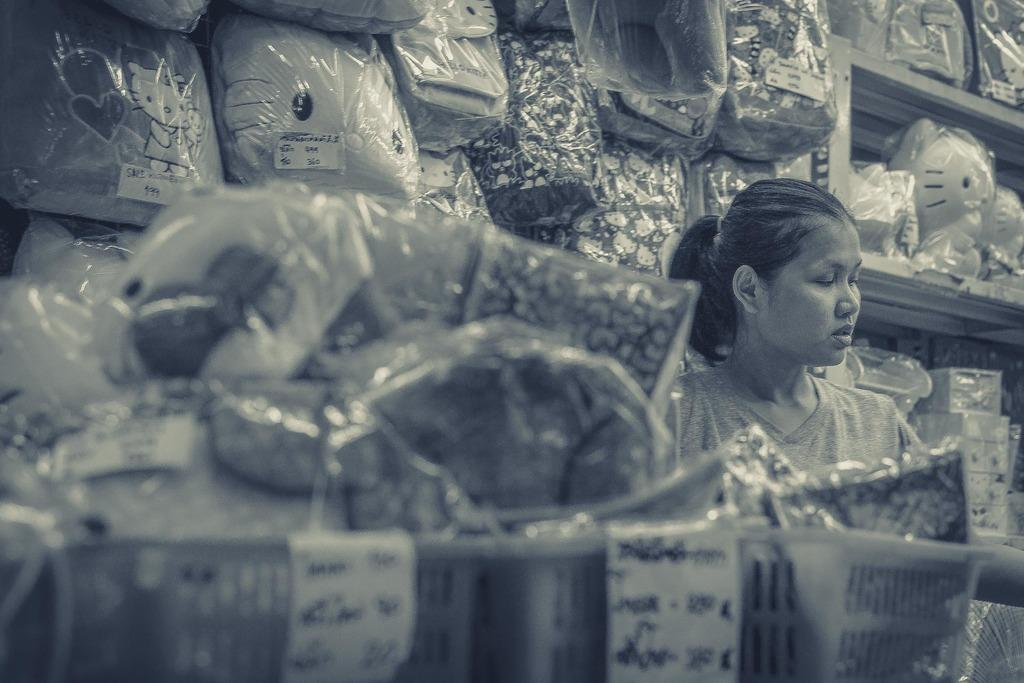Who is present in the image? There is a woman in the image. What can be seen around the woman? There are objects placed on shelves around the woman. What type of straw is the woman using to breathe underwater in the image? There is no straw or underwater activity present in the image; it features a woman with objects on shelves around her. 